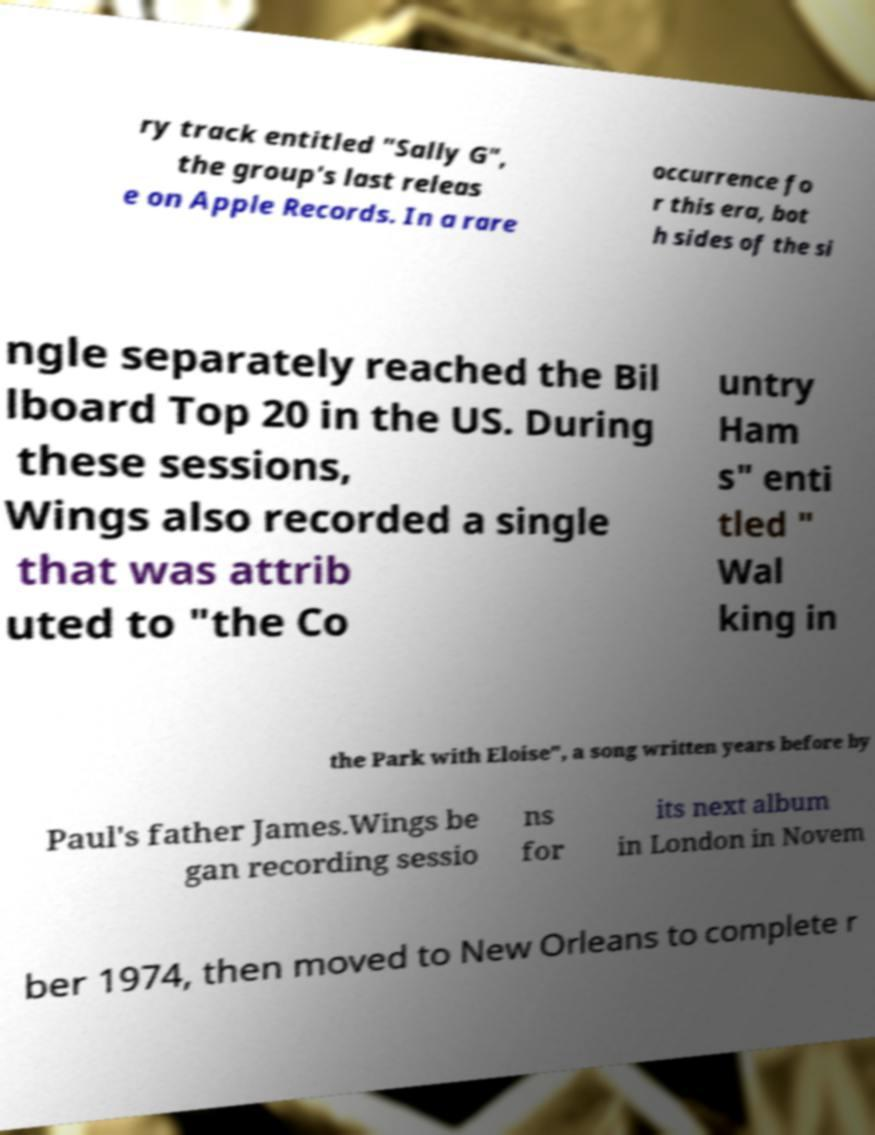Please read and relay the text visible in this image. What does it say? ry track entitled "Sally G", the group's last releas e on Apple Records. In a rare occurrence fo r this era, bot h sides of the si ngle separately reached the Bil lboard Top 20 in the US. During these sessions, Wings also recorded a single that was attrib uted to "the Co untry Ham s" enti tled " Wal king in the Park with Eloise", a song written years before by Paul's father James.Wings be gan recording sessio ns for its next album in London in Novem ber 1974, then moved to New Orleans to complete r 